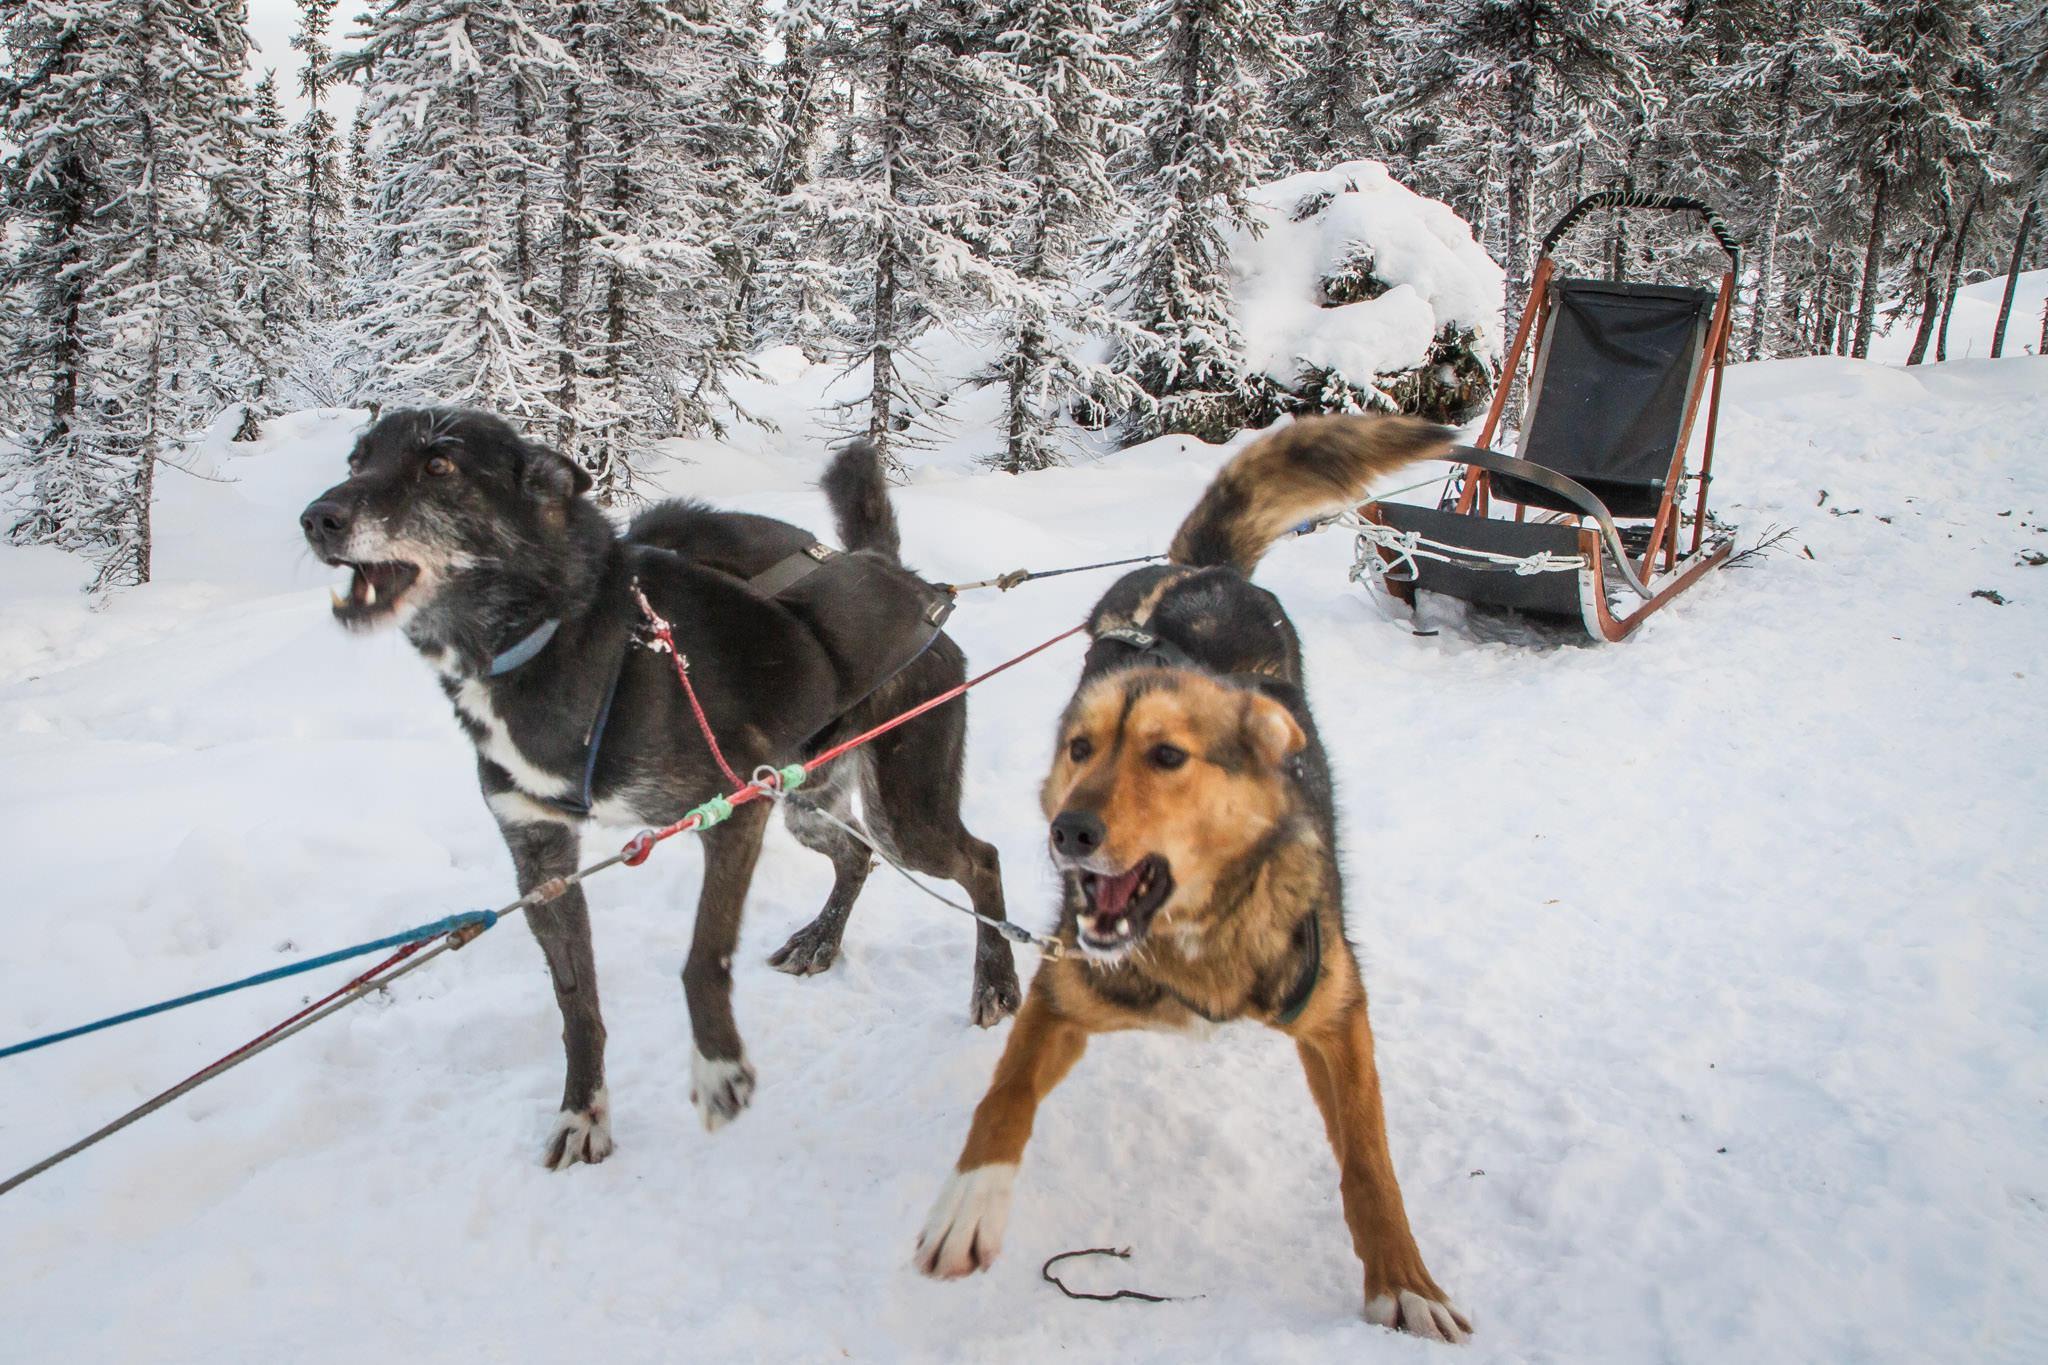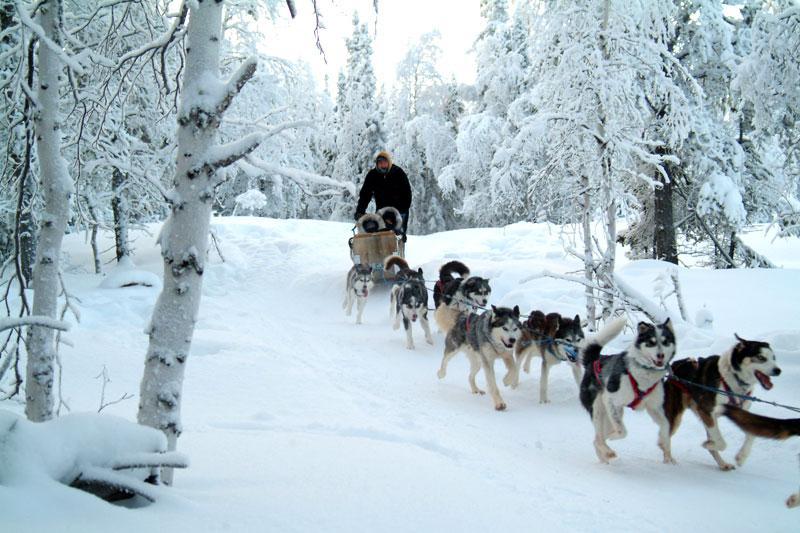The first image is the image on the left, the second image is the image on the right. For the images shown, is this caption "There are multiple persons being pulled by the dogs in the image on the left." true? Answer yes or no. No. The first image is the image on the left, the second image is the image on the right. Considering the images on both sides, is "At least one rider wearing a fur-trimmed head covering is visible in one dog sled image, and the front-most sled in the other image has no seated passenger." valid? Answer yes or no. Yes. 